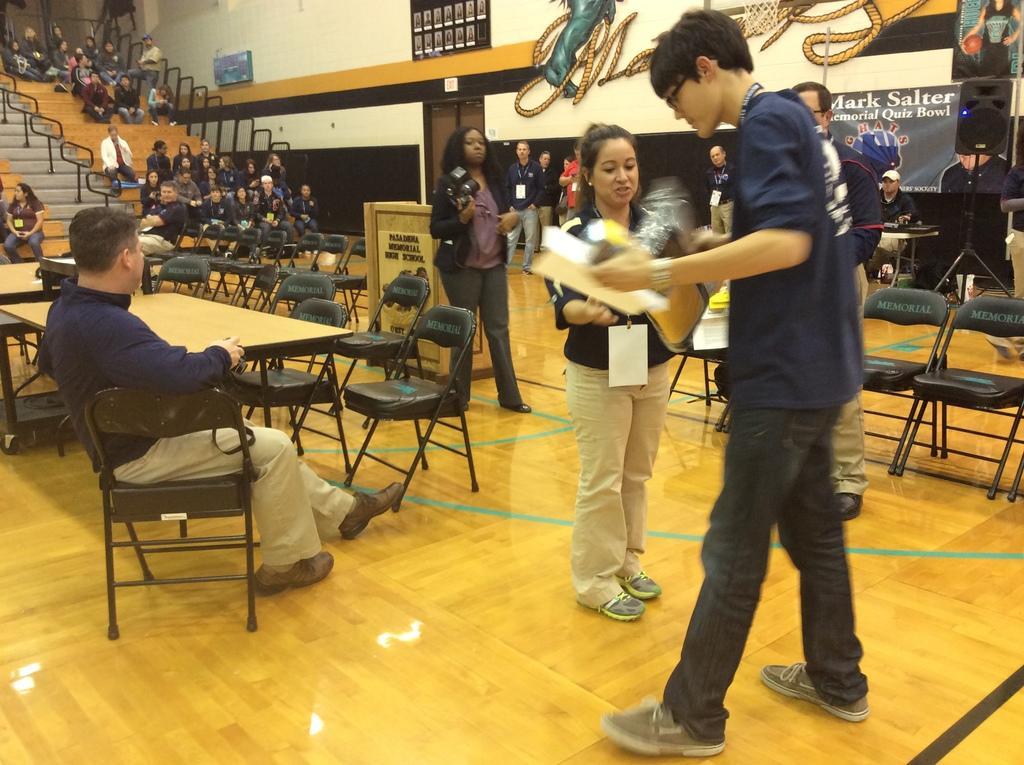Please provide a concise description of this image. In this picture we have a group of people standing and another group of people sitting in the chairs and in the back ground we have banner , speaker , chair , table. 